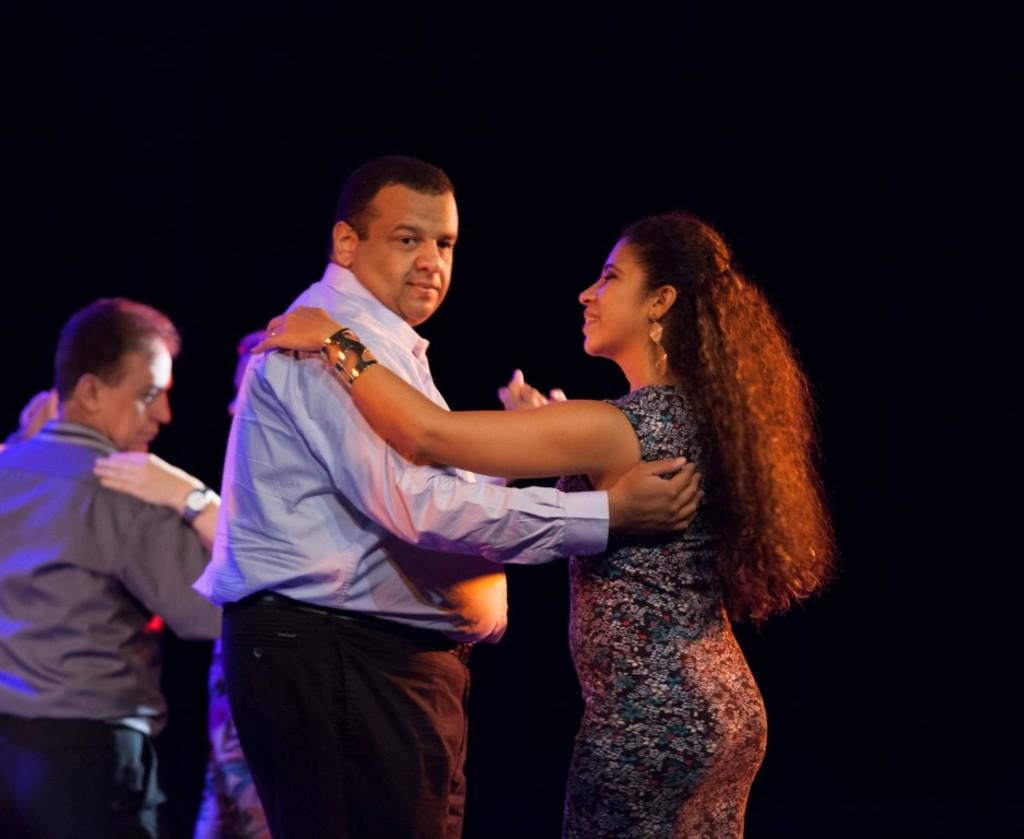How many people are in the image? There are two persons standing in the image. What are the people wearing? Both persons are wearing clothes. Can you describe the position of one of the persons in the image? There is a person in the bottom left of the image wearing clothes. What type of hall can be seen in the background of the image? There is no hall visible in the background of the image. 